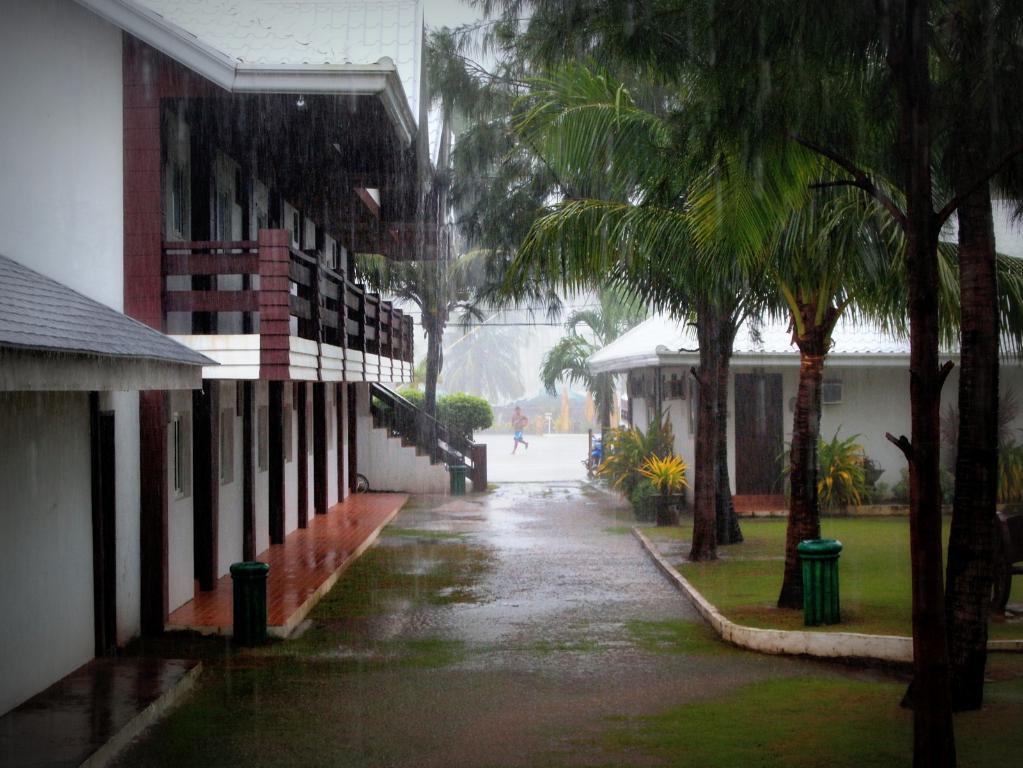Describe this image in one or two sentences. In this image I can see a path in the centre and on it I can see one person. On the right side of the image I can see a grass ground and a green colour thing on the ground. On the both sides of the path I can see few buildings, number of plants and few trees. 